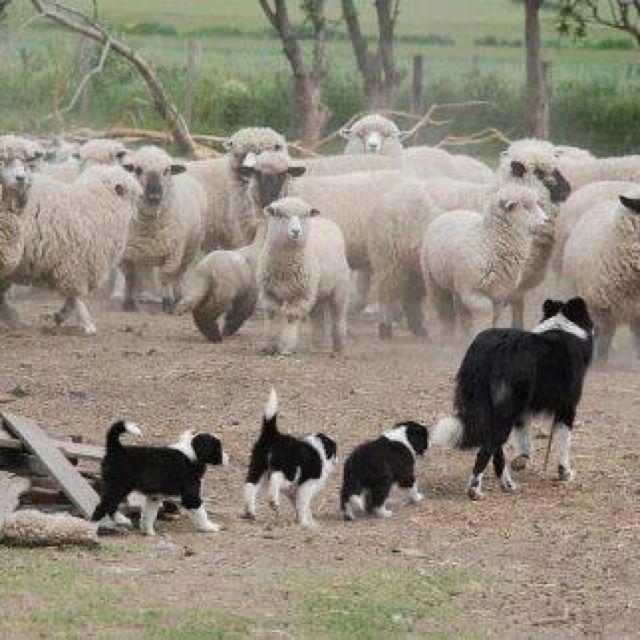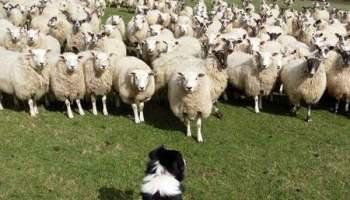The first image is the image on the left, the second image is the image on the right. Examine the images to the left and right. Is the description "An image shows one dog in foreground facing a mass of sheep at the rear of image." accurate? Answer yes or no. Yes. The first image is the image on the left, the second image is the image on the right. Evaluate the accuracy of this statement regarding the images: "One of the images shows exactly one dog with one sheep.". Is it true? Answer yes or no. No. 